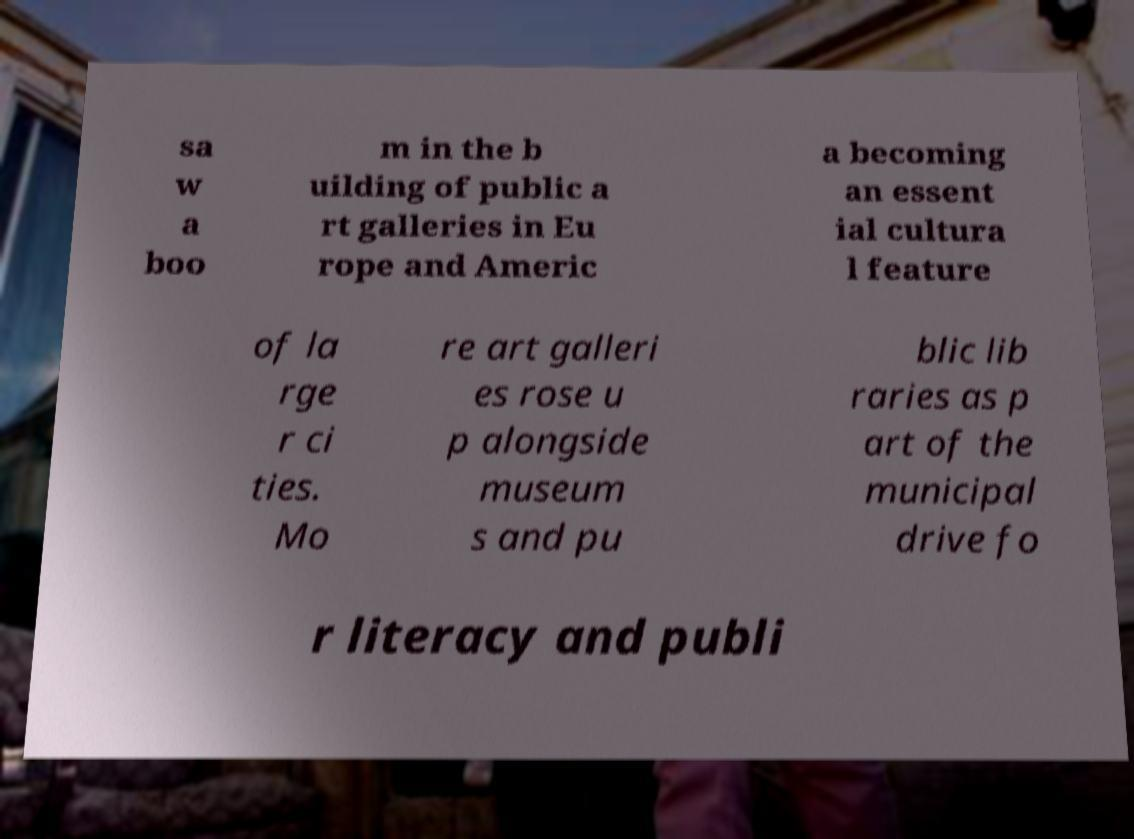I need the written content from this picture converted into text. Can you do that? sa w a boo m in the b uilding of public a rt galleries in Eu rope and Americ a becoming an essent ial cultura l feature of la rge r ci ties. Mo re art galleri es rose u p alongside museum s and pu blic lib raries as p art of the municipal drive fo r literacy and publi 